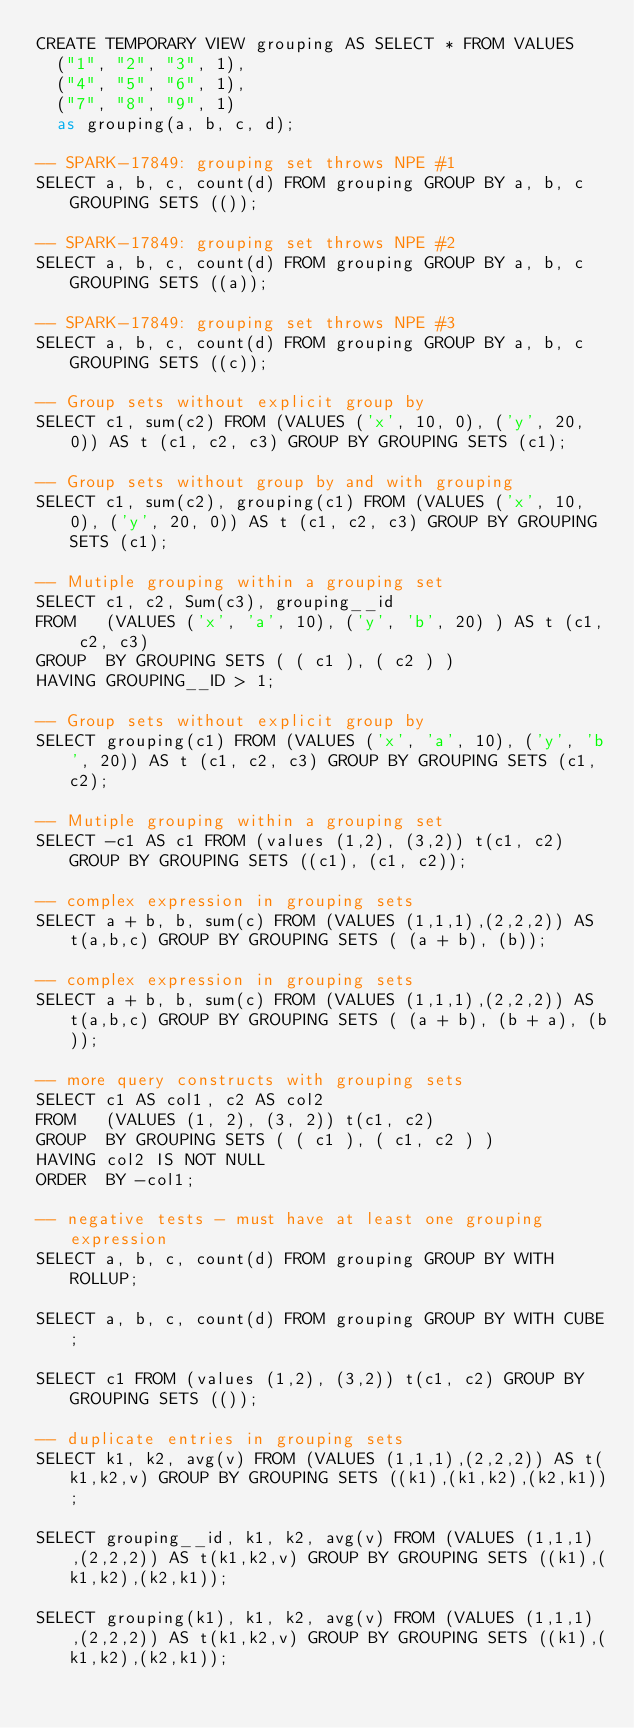<code> <loc_0><loc_0><loc_500><loc_500><_SQL_>CREATE TEMPORARY VIEW grouping AS SELECT * FROM VALUES
  ("1", "2", "3", 1),
  ("4", "5", "6", 1),
  ("7", "8", "9", 1)
  as grouping(a, b, c, d);

-- SPARK-17849: grouping set throws NPE #1
SELECT a, b, c, count(d) FROM grouping GROUP BY a, b, c GROUPING SETS (());

-- SPARK-17849: grouping set throws NPE #2
SELECT a, b, c, count(d) FROM grouping GROUP BY a, b, c GROUPING SETS ((a));

-- SPARK-17849: grouping set throws NPE #3
SELECT a, b, c, count(d) FROM grouping GROUP BY a, b, c GROUPING SETS ((c));

-- Group sets without explicit group by
SELECT c1, sum(c2) FROM (VALUES ('x', 10, 0), ('y', 20, 0)) AS t (c1, c2, c3) GROUP BY GROUPING SETS (c1);

-- Group sets without group by and with grouping
SELECT c1, sum(c2), grouping(c1) FROM (VALUES ('x', 10, 0), ('y', 20, 0)) AS t (c1, c2, c3) GROUP BY GROUPING SETS (c1);

-- Mutiple grouping within a grouping set
SELECT c1, c2, Sum(c3), grouping__id
FROM   (VALUES ('x', 'a', 10), ('y', 'b', 20) ) AS t (c1, c2, c3)
GROUP  BY GROUPING SETS ( ( c1 ), ( c2 ) )
HAVING GROUPING__ID > 1;

-- Group sets without explicit group by
SELECT grouping(c1) FROM (VALUES ('x', 'a', 10), ('y', 'b', 20)) AS t (c1, c2, c3) GROUP BY GROUPING SETS (c1,c2);

-- Mutiple grouping within a grouping set
SELECT -c1 AS c1 FROM (values (1,2), (3,2)) t(c1, c2) GROUP BY GROUPING SETS ((c1), (c1, c2));

-- complex expression in grouping sets
SELECT a + b, b, sum(c) FROM (VALUES (1,1,1),(2,2,2)) AS t(a,b,c) GROUP BY GROUPING SETS ( (a + b), (b));

-- complex expression in grouping sets
SELECT a + b, b, sum(c) FROM (VALUES (1,1,1),(2,2,2)) AS t(a,b,c) GROUP BY GROUPING SETS ( (a + b), (b + a), (b));

-- more query constructs with grouping sets
SELECT c1 AS col1, c2 AS col2
FROM   (VALUES (1, 2), (3, 2)) t(c1, c2)
GROUP  BY GROUPING SETS ( ( c1 ), ( c1, c2 ) )
HAVING col2 IS NOT NULL
ORDER  BY -col1;

-- negative tests - must have at least one grouping expression
SELECT a, b, c, count(d) FROM grouping GROUP BY WITH ROLLUP;

SELECT a, b, c, count(d) FROM grouping GROUP BY WITH CUBE;

SELECT c1 FROM (values (1,2), (3,2)) t(c1, c2) GROUP BY GROUPING SETS (());

-- duplicate entries in grouping sets
SELECT k1, k2, avg(v) FROM (VALUES (1,1,1),(2,2,2)) AS t(k1,k2,v) GROUP BY GROUPING SETS ((k1),(k1,k2),(k2,k1));

SELECT grouping__id, k1, k2, avg(v) FROM (VALUES (1,1,1),(2,2,2)) AS t(k1,k2,v) GROUP BY GROUPING SETS ((k1),(k1,k2),(k2,k1));

SELECT grouping(k1), k1, k2, avg(v) FROM (VALUES (1,1,1),(2,2,2)) AS t(k1,k2,v) GROUP BY GROUPING SETS ((k1),(k1,k2),(k2,k1));
</code> 